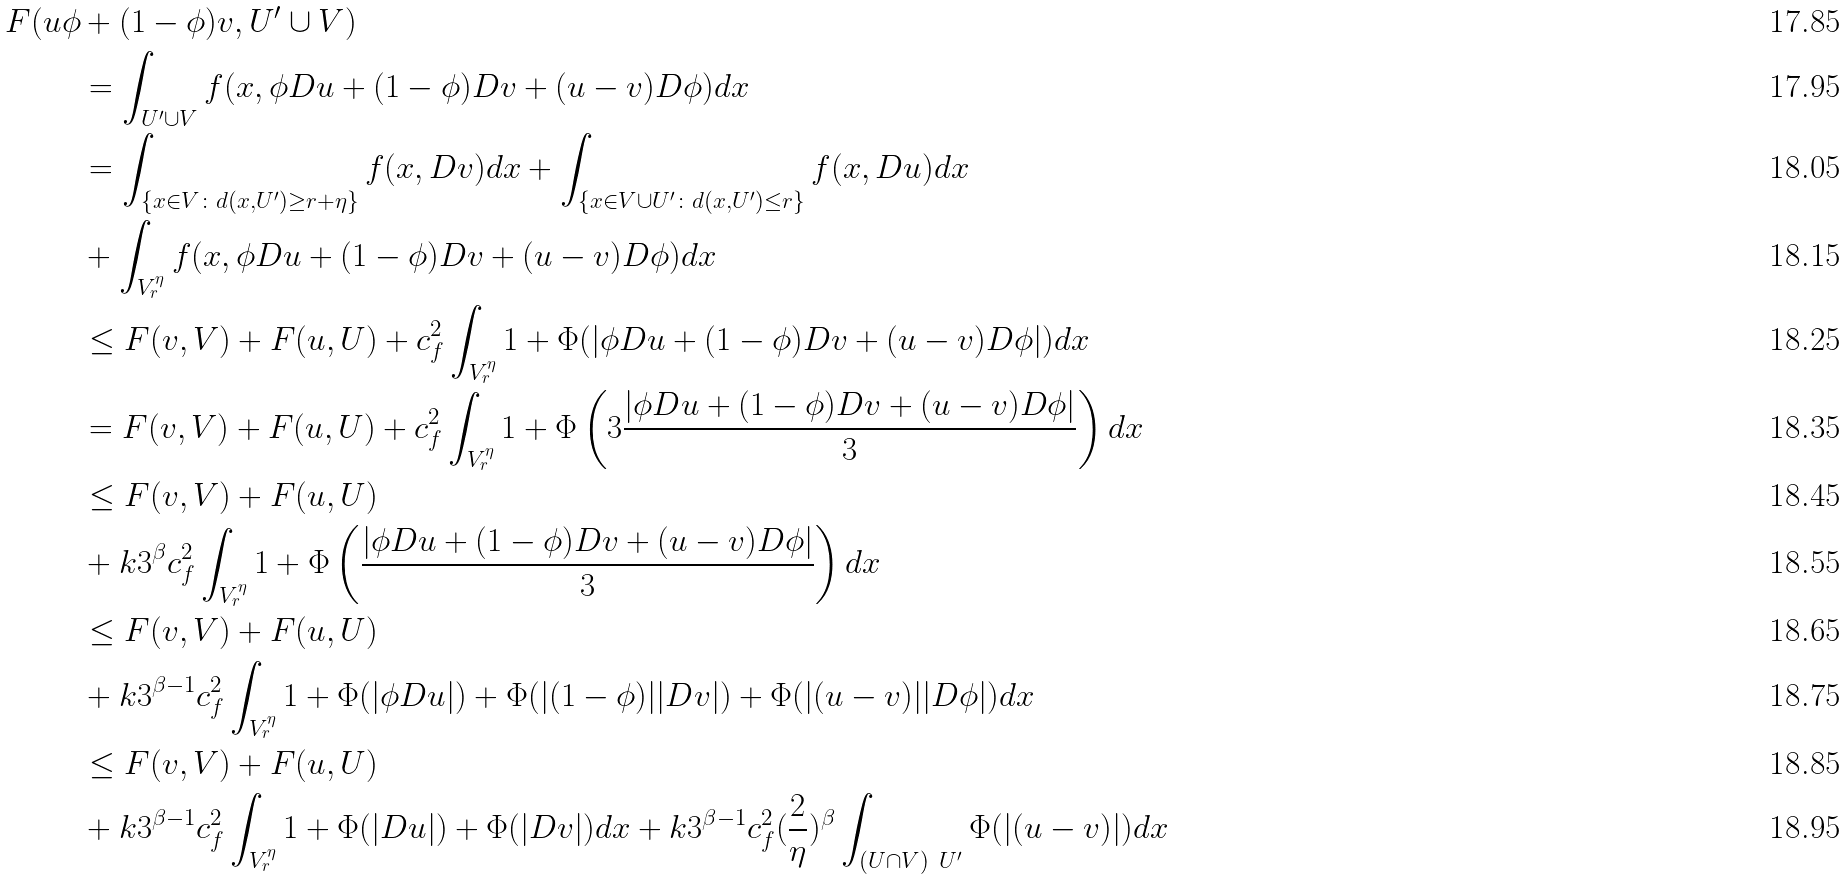<formula> <loc_0><loc_0><loc_500><loc_500>F ( u \phi & + ( 1 - \phi ) v , U ^ { \prime } \cup V ) \\ & = \int _ { U ^ { \prime } \cup V } f ( x , \phi D u + ( 1 - \phi ) D v + ( u - v ) D \phi ) d x \\ & = \int _ { \{ x \in V \colon d ( x , U ^ { \prime } ) \geq r + \eta \} } f ( x , D v ) d x + \int _ { \{ x \in V \cup U ^ { \prime } \colon d ( x , U ^ { \prime } ) \leq r \} } f ( x , D u ) d x \\ & + \int _ { V _ { r } ^ { \eta } } f ( x , \phi D u + ( 1 - \phi ) D v + ( u - v ) D \phi ) d x \\ & \leq F ( v , V ) + F ( u , U ) + c ^ { 2 } _ { f } \int _ { V _ { r } ^ { \eta } } 1 + \Phi ( | \phi D u + ( 1 - \phi ) D v + ( u - v ) D \phi | ) d x \\ & = F ( v , V ) + F ( u , U ) + c ^ { 2 } _ { f } \int _ { V _ { r } ^ { \eta } } 1 + \Phi \left ( 3 \frac { | \phi D u + ( 1 - \phi ) D v + ( u - v ) D \phi | } { 3 } \right ) d x \\ & \leq F ( v , V ) + F ( u , U ) \\ & + k 3 ^ { \beta } c ^ { 2 } _ { f } \int _ { V _ { r } ^ { \eta } } 1 + \Phi \left ( \frac { | \phi D u + ( 1 - \phi ) D v + ( u - v ) D \phi | } { 3 } \right ) d x \\ & \leq F ( v , V ) + F ( u , U ) \\ & + k 3 ^ { \beta - 1 } c ^ { 2 } _ { f } \int _ { V _ { r } ^ { \eta } } 1 + \Phi ( | \phi D u | ) + \Phi ( | ( 1 - \phi ) | | D v | ) + \Phi ( | ( u - v ) | | D \phi | ) d x \\ & \leq F ( v , V ) + F ( u , U ) \\ & + k 3 ^ { \beta - 1 } c ^ { 2 } _ { f } \int _ { V _ { r } ^ { \eta } } 1 + \Phi ( | D u | ) + \Phi ( | D v | ) d x + k 3 ^ { \beta - 1 } c ^ { 2 } _ { f } ( \frac { 2 } { \eta } ) ^ { \beta } \int _ { ( U \cap V ) \ U ^ { \prime } } \Phi ( | ( u - v ) | ) d x</formula> 